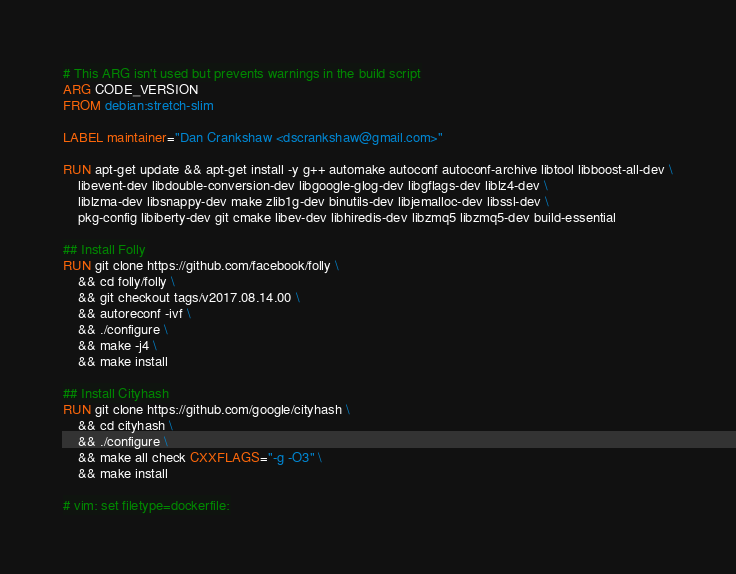<code> <loc_0><loc_0><loc_500><loc_500><_Dockerfile_># This ARG isn't used but prevents warnings in the build script
ARG CODE_VERSION
FROM debian:stretch-slim

LABEL maintainer="Dan Crankshaw <dscrankshaw@gmail.com>"

RUN apt-get update && apt-get install -y g++ automake autoconf autoconf-archive libtool libboost-all-dev \
    libevent-dev libdouble-conversion-dev libgoogle-glog-dev libgflags-dev liblz4-dev \
    liblzma-dev libsnappy-dev make zlib1g-dev binutils-dev libjemalloc-dev libssl-dev \
    pkg-config libiberty-dev git cmake libev-dev libhiredis-dev libzmq5 libzmq5-dev build-essential

## Install Folly
RUN git clone https://github.com/facebook/folly \
    && cd folly/folly \
    && git checkout tags/v2017.08.14.00 \
    && autoreconf -ivf \
    && ./configure \
    && make -j4 \
    && make install

## Install Cityhash
RUN git clone https://github.com/google/cityhash \
    && cd cityhash \
    && ./configure \
    && make all check CXXFLAGS="-g -O3" \
    && make install

# vim: set filetype=dockerfile:
</code> 